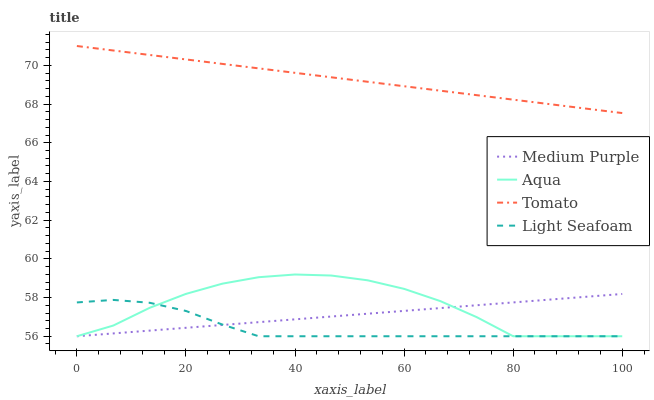Does Light Seafoam have the minimum area under the curve?
Answer yes or no. Yes. Does Tomato have the maximum area under the curve?
Answer yes or no. Yes. Does Tomato have the minimum area under the curve?
Answer yes or no. No. Does Light Seafoam have the maximum area under the curve?
Answer yes or no. No. Is Medium Purple the smoothest?
Answer yes or no. Yes. Is Aqua the roughest?
Answer yes or no. Yes. Is Tomato the smoothest?
Answer yes or no. No. Is Tomato the roughest?
Answer yes or no. No. Does Medium Purple have the lowest value?
Answer yes or no. Yes. Does Tomato have the lowest value?
Answer yes or no. No. Does Tomato have the highest value?
Answer yes or no. Yes. Does Light Seafoam have the highest value?
Answer yes or no. No. Is Aqua less than Tomato?
Answer yes or no. Yes. Is Tomato greater than Aqua?
Answer yes or no. Yes. Does Medium Purple intersect Aqua?
Answer yes or no. Yes. Is Medium Purple less than Aqua?
Answer yes or no. No. Is Medium Purple greater than Aqua?
Answer yes or no. No. Does Aqua intersect Tomato?
Answer yes or no. No. 